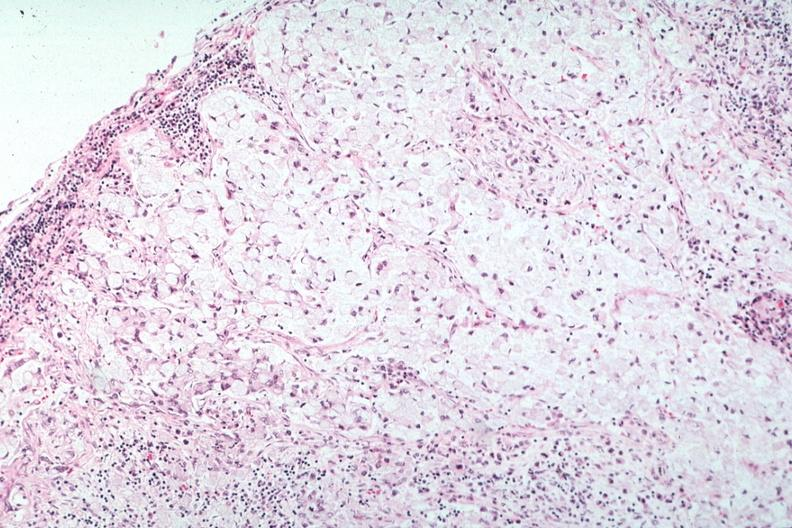what does this image show?
Answer the question using a single word or phrase. Stomach primary 